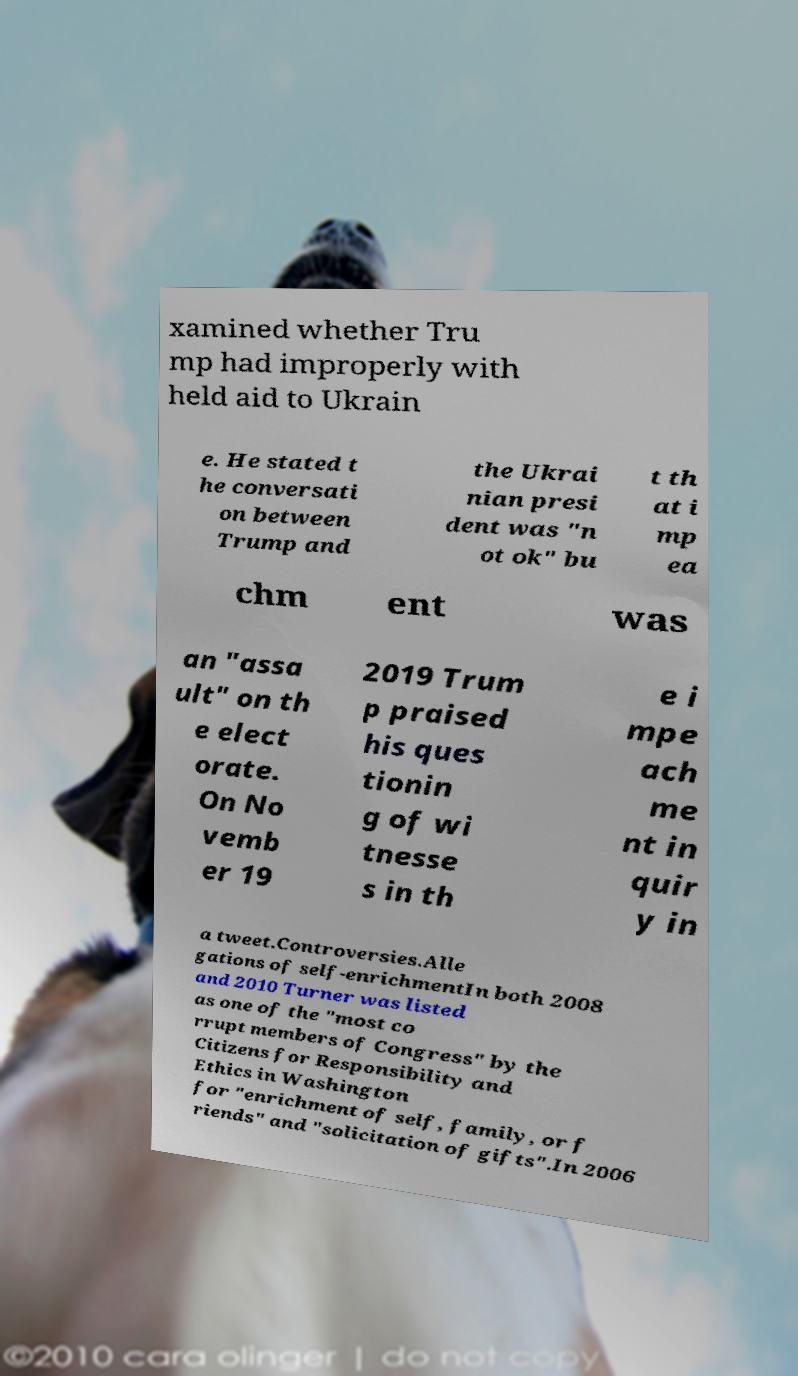Please read and relay the text visible in this image. What does it say? xamined whether Tru mp had improperly with held aid to Ukrain e. He stated t he conversati on between Trump and the Ukrai nian presi dent was "n ot ok" bu t th at i mp ea chm ent was an "assa ult" on th e elect orate. On No vemb er 19 2019 Trum p praised his ques tionin g of wi tnesse s in th e i mpe ach me nt in quir y in a tweet.Controversies.Alle gations of self-enrichmentIn both 2008 and 2010 Turner was listed as one of the "most co rrupt members of Congress" by the Citizens for Responsibility and Ethics in Washington for "enrichment of self, family, or f riends" and "solicitation of gifts".In 2006 